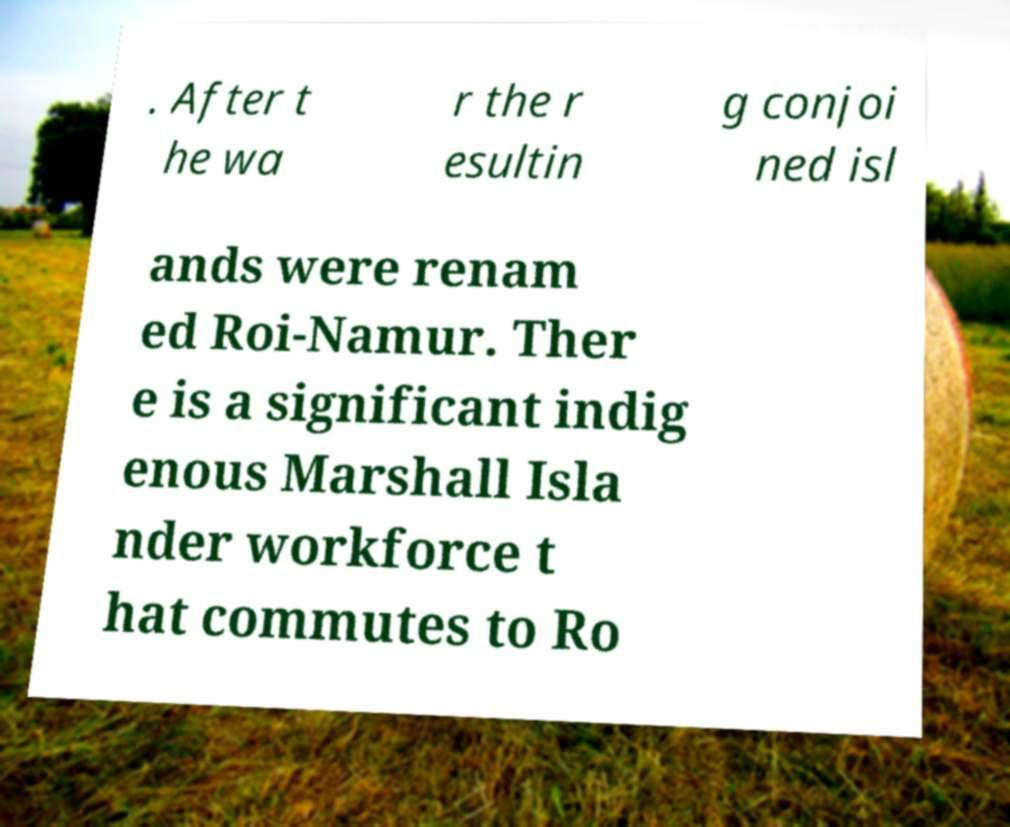Can you read and provide the text displayed in the image?This photo seems to have some interesting text. Can you extract and type it out for me? . After t he wa r the r esultin g conjoi ned isl ands were renam ed Roi-Namur. Ther e is a significant indig enous Marshall Isla nder workforce t hat commutes to Ro 